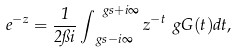Convert formula to latex. <formula><loc_0><loc_0><loc_500><loc_500>e ^ { - z } = \frac { 1 } { 2 \pi i } \int _ { \ g s - i \infty } ^ { \ g s + i \infty } z ^ { - t } \ g G ( t ) d t ,</formula> 